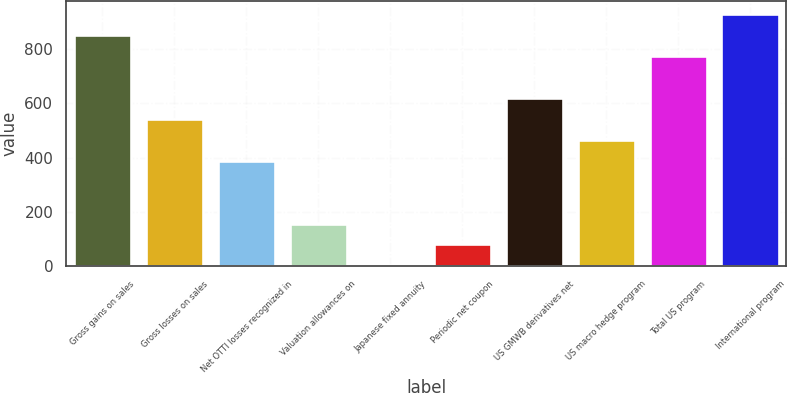Convert chart to OTSL. <chart><loc_0><loc_0><loc_500><loc_500><bar_chart><fcel>Gross gains on sales<fcel>Gross losses on sales<fcel>Net OTTI losses recognized in<fcel>Valuation allowances on<fcel>Japanese fixed annuity<fcel>Periodic net coupon<fcel>US GMWB derivatives net<fcel>US macro hedge program<fcel>Total US program<fcel>International program<nl><fcel>852.2<fcel>543.4<fcel>389<fcel>157.4<fcel>3<fcel>80.2<fcel>620.6<fcel>466.2<fcel>775<fcel>929.4<nl></chart> 